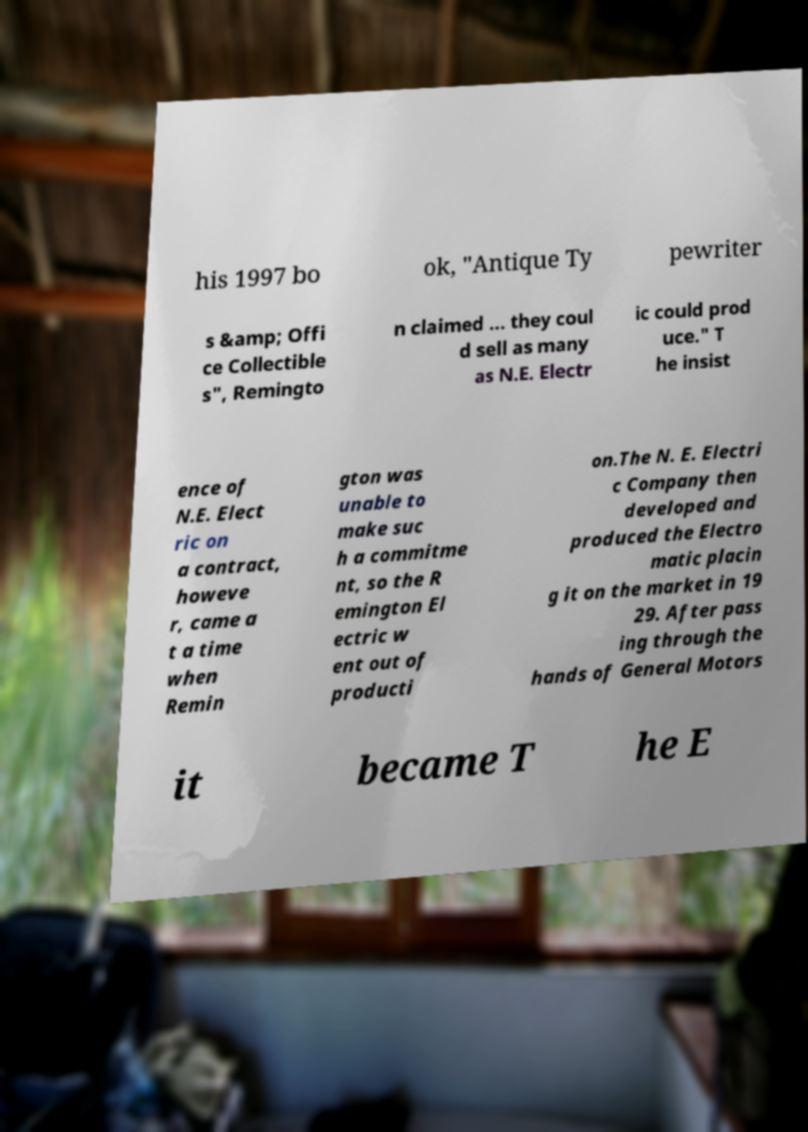Please read and relay the text visible in this image. What does it say? his 1997 bo ok, "Antique Ty pewriter s &amp; Offi ce Collectible s", Remingto n claimed ... they coul d sell as many as N.E. Electr ic could prod uce." T he insist ence of N.E. Elect ric on a contract, howeve r, came a t a time when Remin gton was unable to make suc h a commitme nt, so the R emington El ectric w ent out of producti on.The N. E. Electri c Company then developed and produced the Electro matic placin g it on the market in 19 29. After pass ing through the hands of General Motors it became T he E 